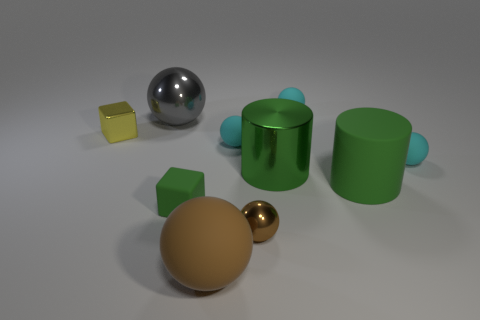Subtract all cyan spheres. How many were subtracted if there are1cyan spheres left? 2 Subtract all brown blocks. How many cyan balls are left? 3 Subtract 3 spheres. How many spheres are left? 3 Subtract all tiny metal spheres. How many spheres are left? 5 Subtract all brown spheres. How many spheres are left? 4 Subtract all purple balls. Subtract all gray cubes. How many balls are left? 6 Subtract all cylinders. How many objects are left? 8 Subtract all small metallic blocks. Subtract all brown things. How many objects are left? 7 Add 3 yellow metal cubes. How many yellow metal cubes are left? 4 Add 3 matte cylinders. How many matte cylinders exist? 4 